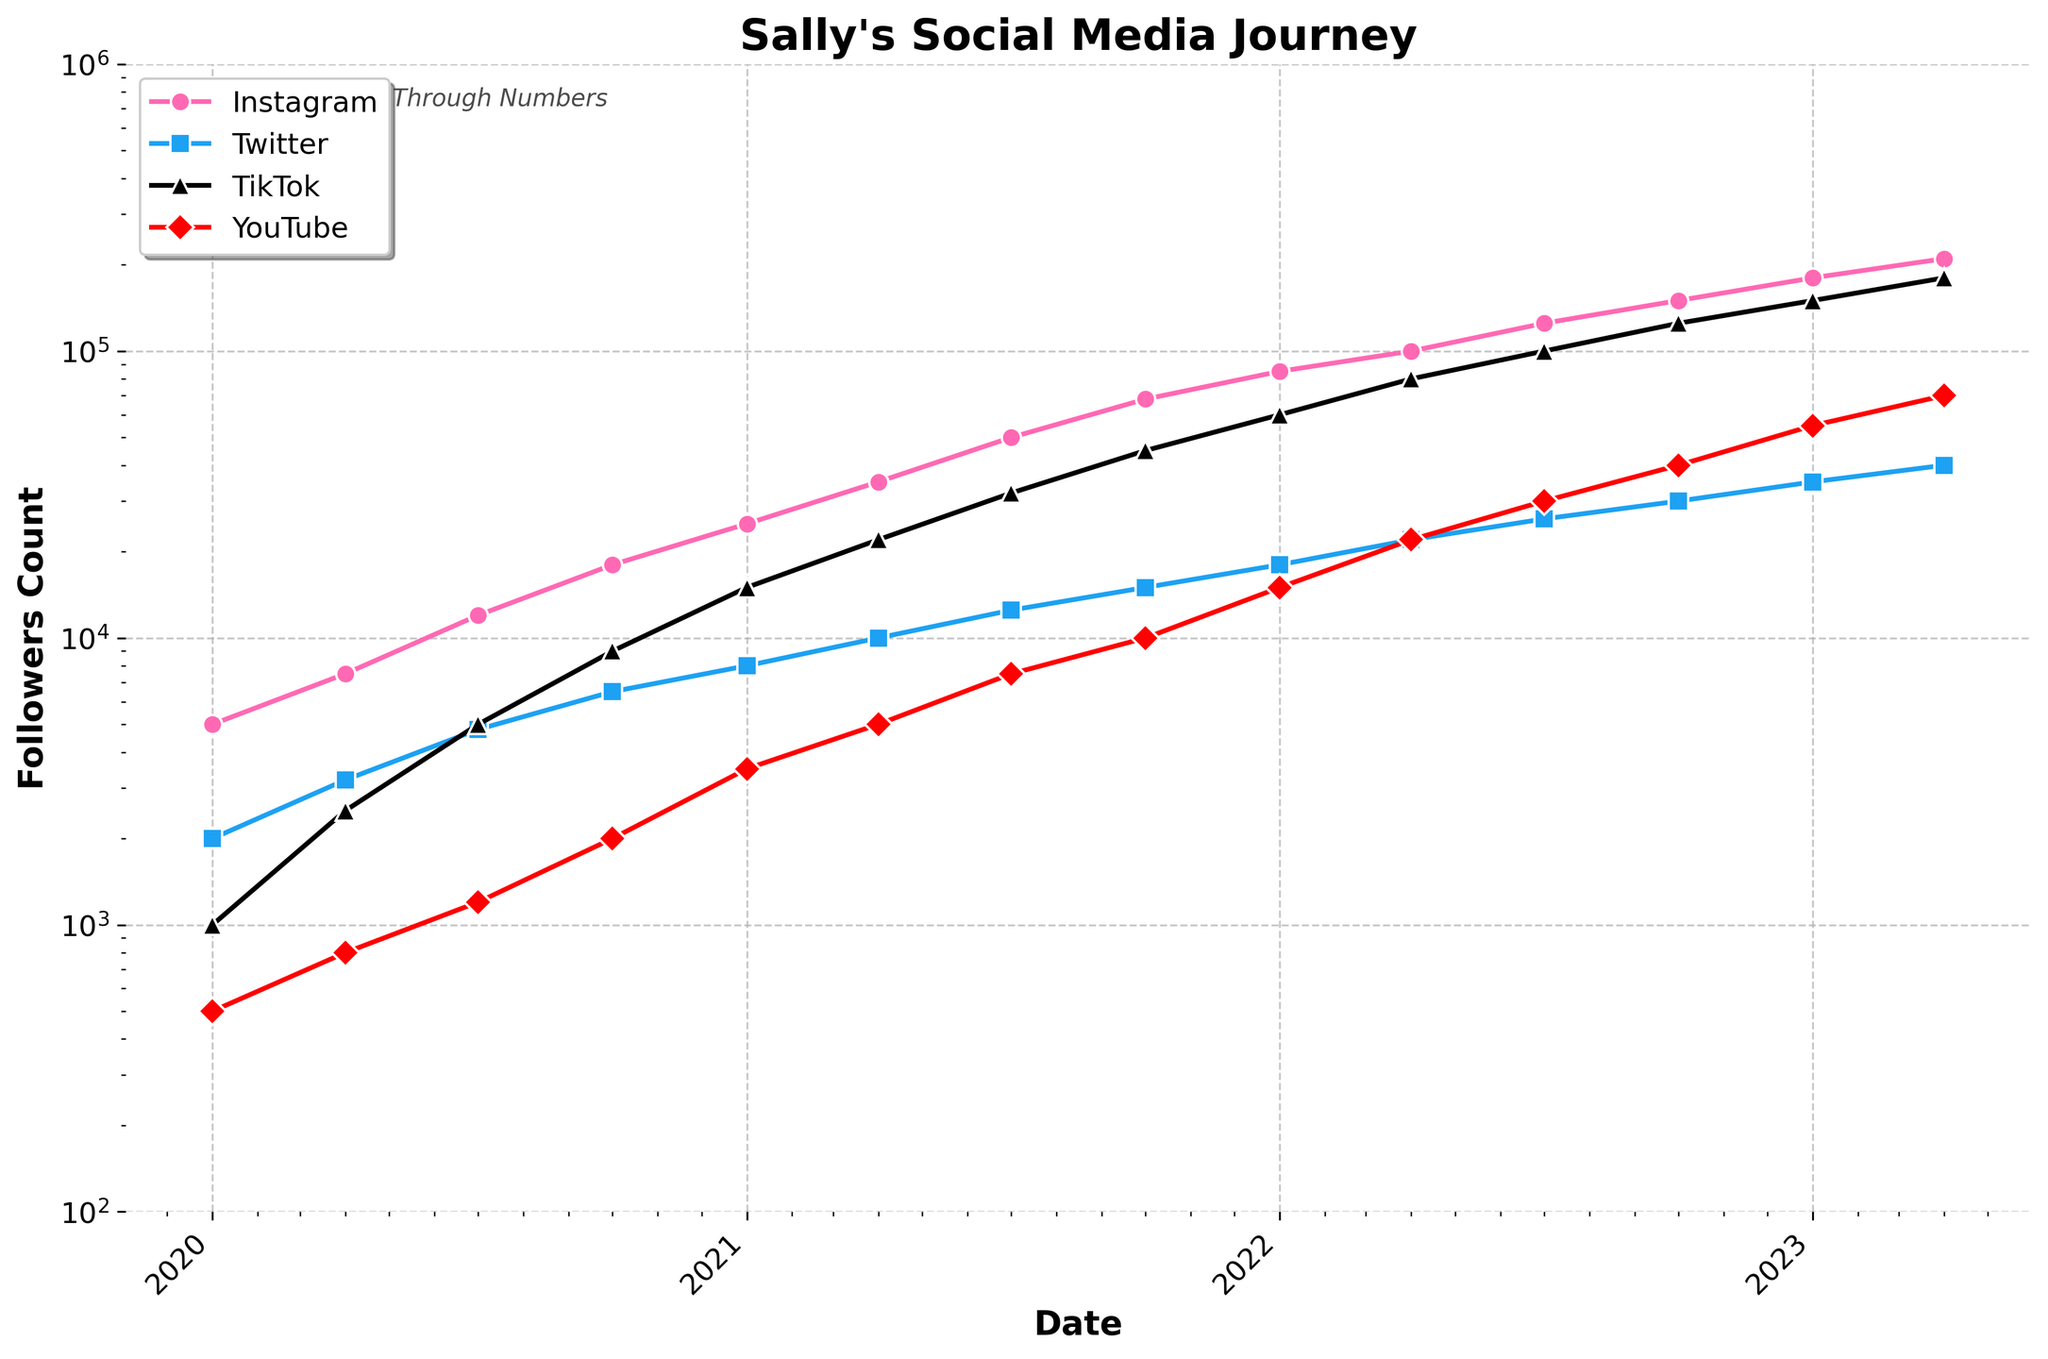Which social media platform showed the greatest increase in follower count from 2022-10-01 to 2023-04-01? To find the greatest increase, we compare the follower counts on 2022-10-01 and 2023-04-01 for all platforms. TikTok increased from 125,000 to 180,000 (55,000 increase), which is the highest compared to others.
Answer: TikTok How much did Sally's Instagram followers grow in the year 2022? We look at Sally's Instagram followers on 2022-01-01 and 2023-01-01. On 2022-01-01, she had 85,000 followers and on 2023-01-01, she had 150,000 followers. The difference is 150,000 - 85,000 = 65,000.
Answer: 65,000 Which platform had the least followers on 2020-01-01, and what was the follower count? We compare the follower counts on 2020-01-01 for all platforms. The lowest value is for YouTube with 500 followers.
Answer: YouTube, 500 What is the average number of followers on TikTok across all given dates? Sum the TikTok followers over all given dates and divide by the number of dates. The follower counts are: 1000, 2500, 5000, 9000, 15000, 22000, 32000, 45000, 60000, 80000, 100000, 125000, 150000, 180000. The sum is 649,500, and there are 14 dates, so the average is 649,500 / 14.
Answer: 46,393 Between which two consecutive dates did Twitter see its sharpest increase in followers, and what was the amount of this increase? We find differences between consecutive dates for Twitter: 2000 to 3200 (1200), 3200 to 4800 (1600), 4800 to 6500 (1700), 6500 to 8000 (1500), 8000 to 10000 (2000), 10000 to 12500 (2500), 12500 to 15000 (2500), 15000 to 18000 (3000), 18000 to 22000 (4000), 22000 to 26000 (4000), 26000 to 30000 (4000), 30000 to 35000 (5000), 35000 to 40000 (5000). The sharpest increase is the last interval, 35000 to 40000 (5000).
Answer: 2023-01-01 to 2023-04-01, 5000 By what percentage did Sally's YouTube followers increase from 2021-01-01 to 2021-04-01? Sally had 3,500 followers on 2021-01-01 and 5,000 on 2021-04-01. The increase is 5000 - 3500 = 1500. To find the percentage increase: (1500 / 3500) * 100 = 42.86%.
Answer: 42.86% Which platform showed consistent growth in each recorded quarter? By visually inspecting all four platforms, we can see that Instagram shows consistent growth in each recorded quarter.
Answer: Instagram 